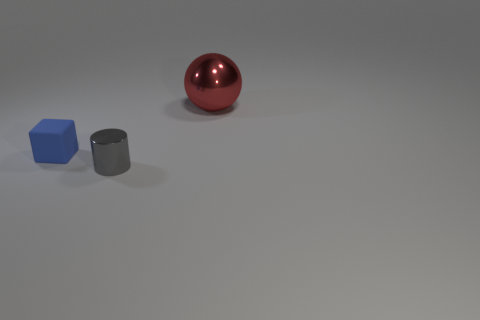What material is the blue block that is the same size as the gray thing?
Provide a succinct answer. Rubber. What is the size of the gray cylinder that is made of the same material as the big ball?
Provide a short and direct response. Small. There is a thing that is both behind the small gray metal object and on the right side of the blue cube; what material is it made of?
Give a very brief answer. Metal. What number of gray metallic things have the same size as the blue matte object?
Offer a terse response. 1. What number of objects are things in front of the large thing or things on the left side of the gray metal cylinder?
Give a very brief answer. 2. Is the shape of the rubber thing the same as the metallic thing in front of the ball?
Provide a succinct answer. No. There is a metallic object that is behind the metallic thing that is to the left of the red shiny object behind the tiny cylinder; what shape is it?
Your answer should be compact. Sphere. What number of other things are there of the same material as the tiny gray thing
Make the answer very short. 1. How many objects are either metallic things right of the small cylinder or gray cylinders?
Give a very brief answer. 2. What shape is the shiny object left of the metallic thing that is behind the tiny gray metal thing?
Give a very brief answer. Cylinder. 